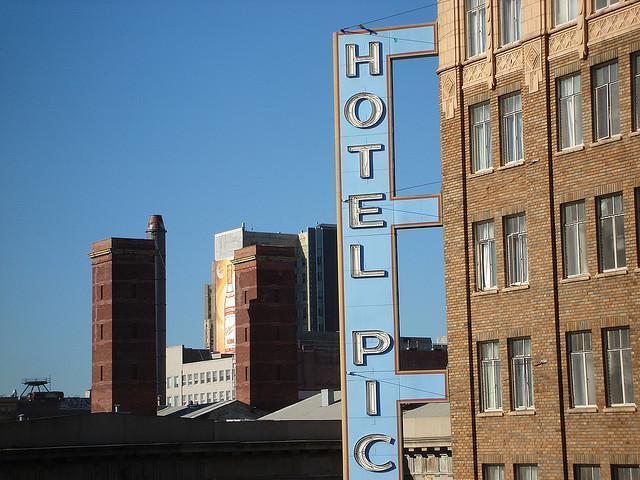How many words do you see?
Give a very brief answer. 2. 